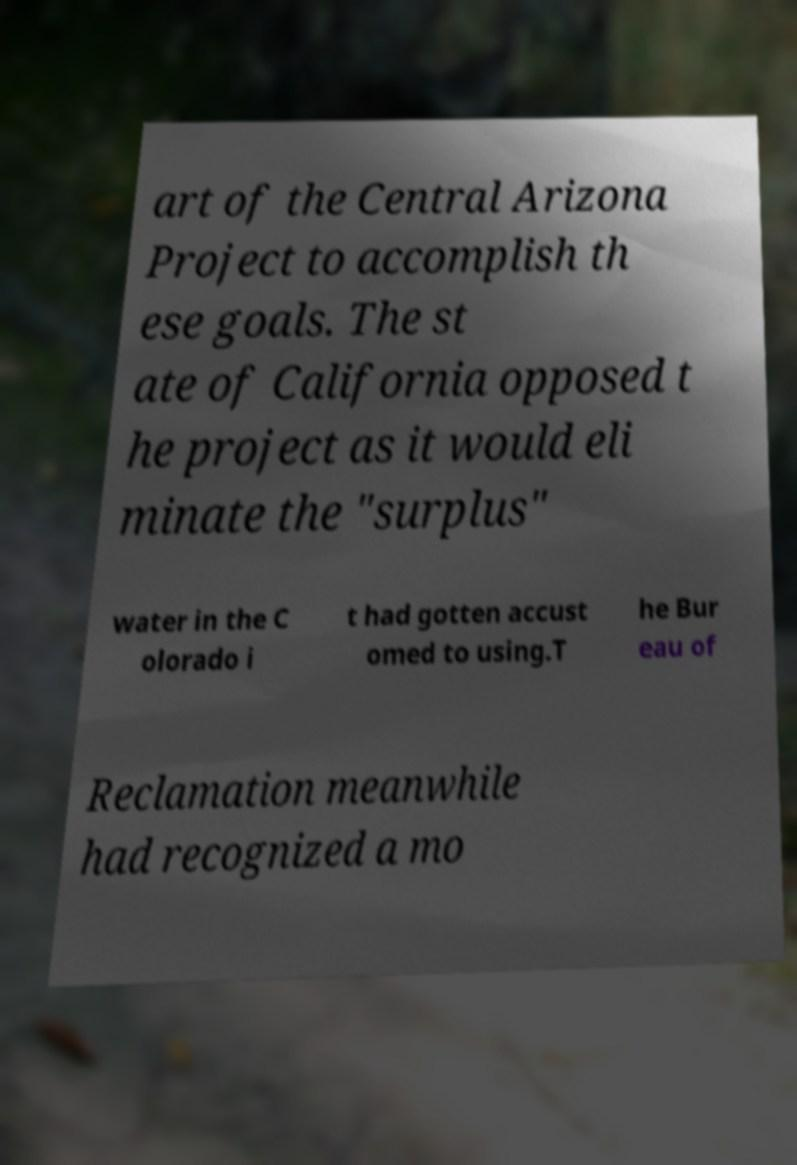What messages or text are displayed in this image? I need them in a readable, typed format. art of the Central Arizona Project to accomplish th ese goals. The st ate of California opposed t he project as it would eli minate the "surplus" water in the C olorado i t had gotten accust omed to using.T he Bur eau of Reclamation meanwhile had recognized a mo 